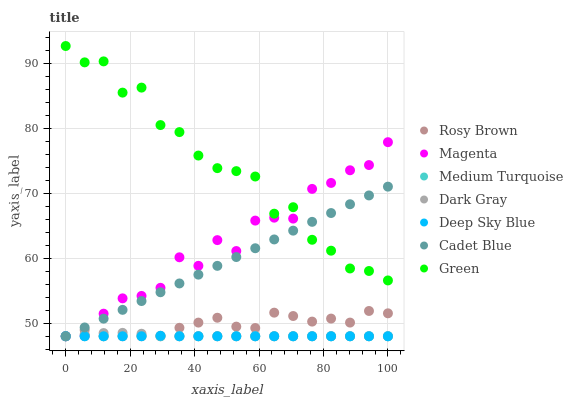Does Deep Sky Blue have the minimum area under the curve?
Answer yes or no. Yes. Does Green have the maximum area under the curve?
Answer yes or no. Yes. Does Medium Turquoise have the minimum area under the curve?
Answer yes or no. No. Does Medium Turquoise have the maximum area under the curve?
Answer yes or no. No. Is Cadet Blue the smoothest?
Answer yes or no. Yes. Is Green the roughest?
Answer yes or no. Yes. Is Medium Turquoise the smoothest?
Answer yes or no. No. Is Medium Turquoise the roughest?
Answer yes or no. No. Does Cadet Blue have the lowest value?
Answer yes or no. Yes. Does Green have the lowest value?
Answer yes or no. No. Does Green have the highest value?
Answer yes or no. Yes. Does Rosy Brown have the highest value?
Answer yes or no. No. Is Dark Gray less than Green?
Answer yes or no. Yes. Is Green greater than Deep Sky Blue?
Answer yes or no. Yes. Does Dark Gray intersect Cadet Blue?
Answer yes or no. Yes. Is Dark Gray less than Cadet Blue?
Answer yes or no. No. Is Dark Gray greater than Cadet Blue?
Answer yes or no. No. Does Dark Gray intersect Green?
Answer yes or no. No. 